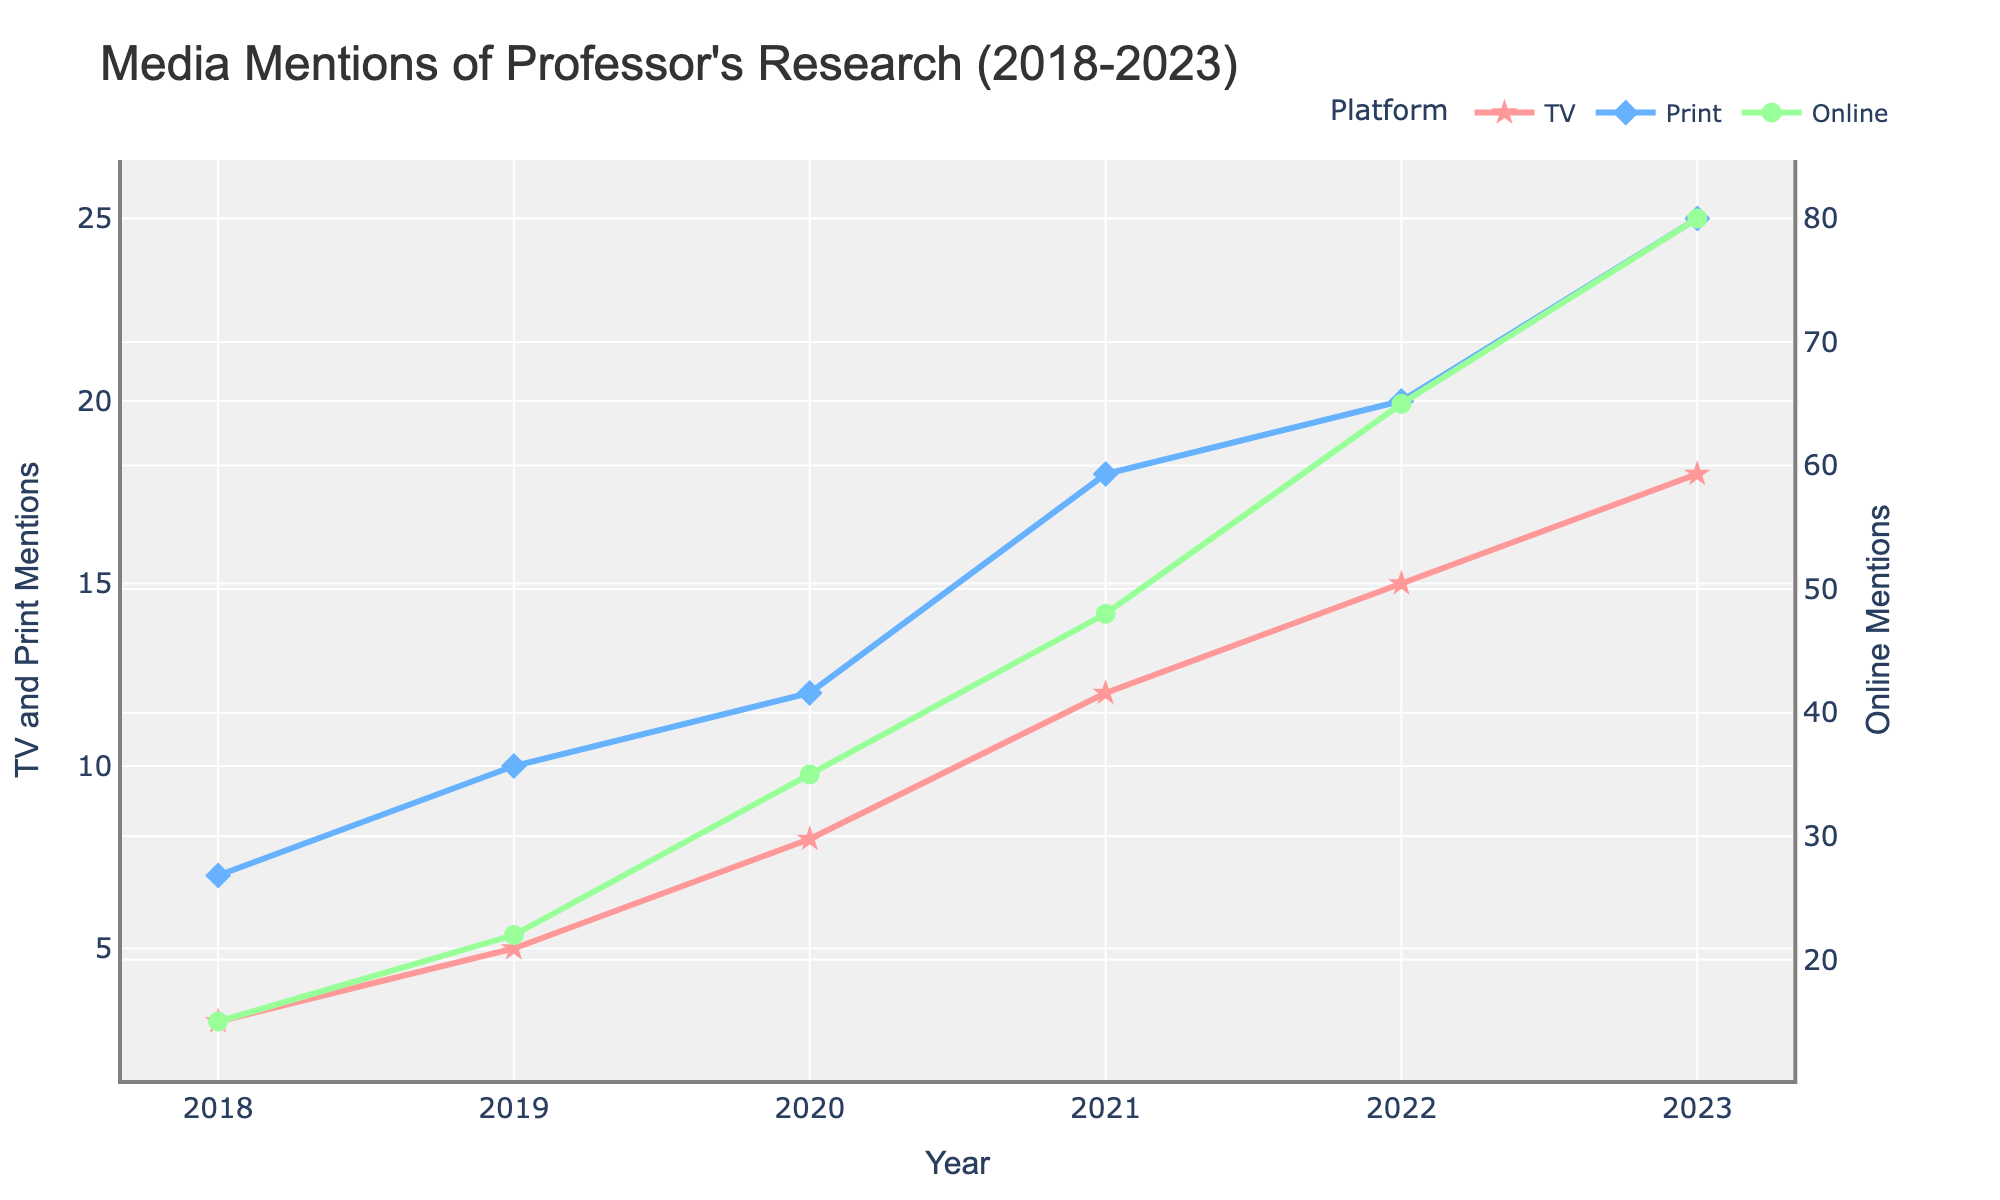What year did online mentions first surpass 50? Looking at the ‘Online’ line, it surpasses 50 in 2021.
Answer: 2021 Which platform had the highest number of mentions in 2023? Observing 2023, the platform with the highest point is 'Online' with 80 mentions.
Answer: Online How many more TV mentions were there in 2023 compared to 2018? Subtract the TV mentions in 2018 from those in 2023: 18 - 3 = 15.
Answer: 15 Did print mentions increase every year? Tracing the 'Print' line from 2018 to 2023, the values continuously increase each year.
Answer: Yes What's the difference between online mentions and print mentions in 2022? Subtract the print mentions from online mentions in 2022: 65 - 20 = 45.
Answer: 45 In which year did TV mentions see the highest year-on-year increase? Calculate the differences year by year: 2019 (5-3=2), 2020 (8-5=3), 2021 (12-8=4), 2022 (15-12=3), 2023 (18-15=3). Highest is in 2021 with an increase of 4.
Answer: 2021 What is the total number of mentions across all platforms in 2020? Sum TV, Print, and Online mentions in 2020: 8 (TV) + 12 (Print) + 35 (Online) = 55.
Answer: 55 Which platform had the most consistent growth pattern? By observing and comparing the slopes of the three lines, the 'Online' mentions show the steadiest and steepest increase.
Answer: Online What is the average number of print mentions from 2018 to 2023? Add all print mentions and divide by the number of years: (7 + 10 + 12 + 18 + 20 + 25) / 6 = 15.33.
Answer: 15.33 Between TV and Print, which platform saw a greater increase in mentions from 2018 to 2023? Calculate the increase: TV from 3 to 18, which is 15; Print from 7 to 25, which is 18. Print saw a greater increase.
Answer: Print 